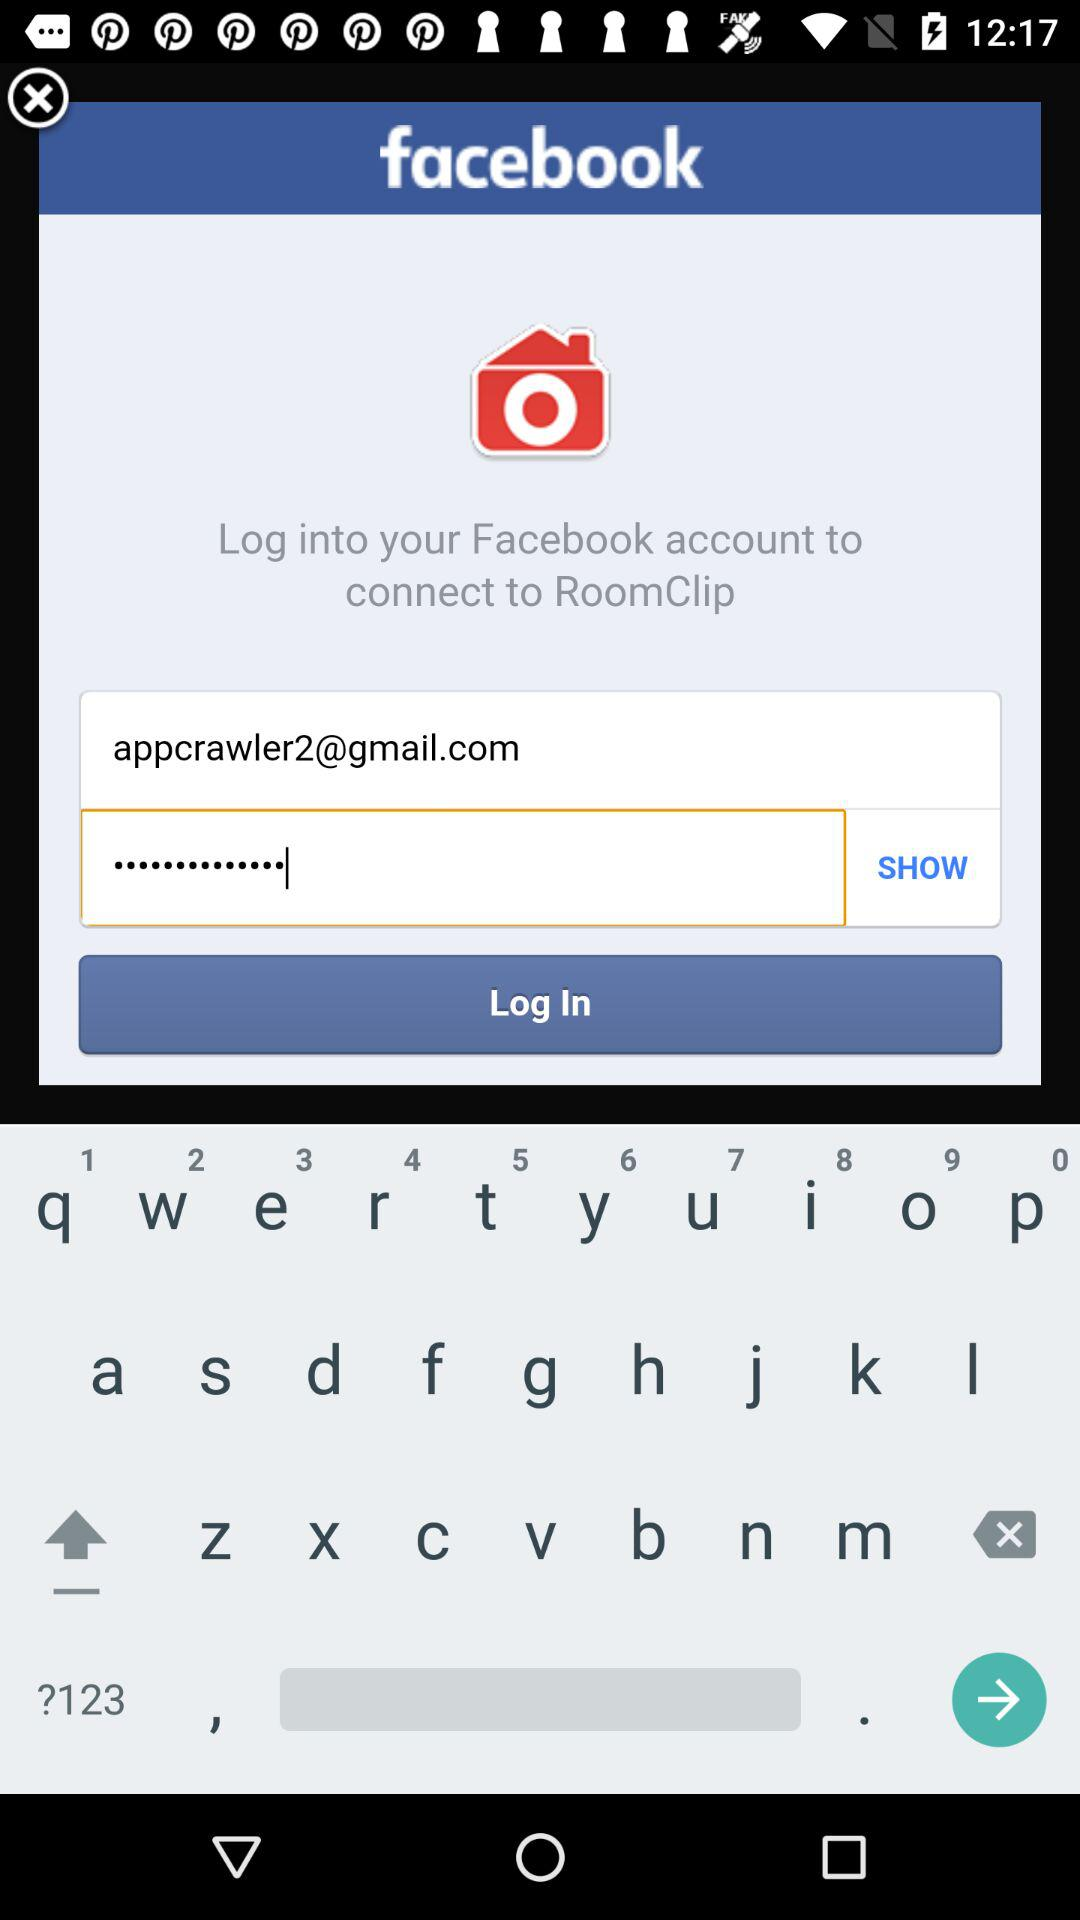What email address is used? The email address is appcrawler2@gmail.com. 